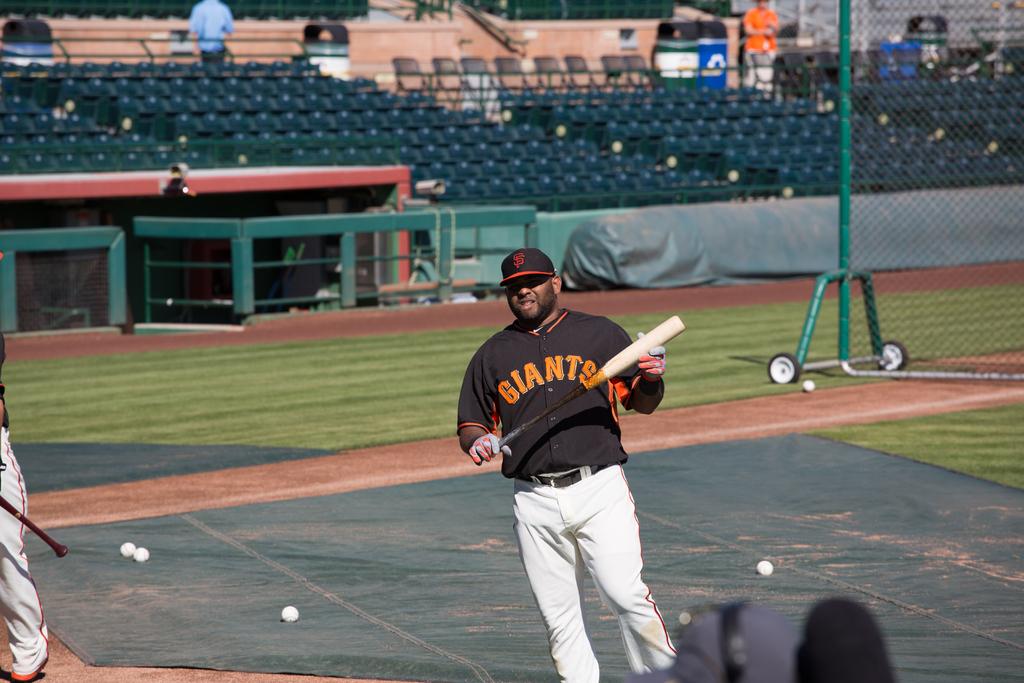What team jersey is that?
Offer a terse response. Giants. 